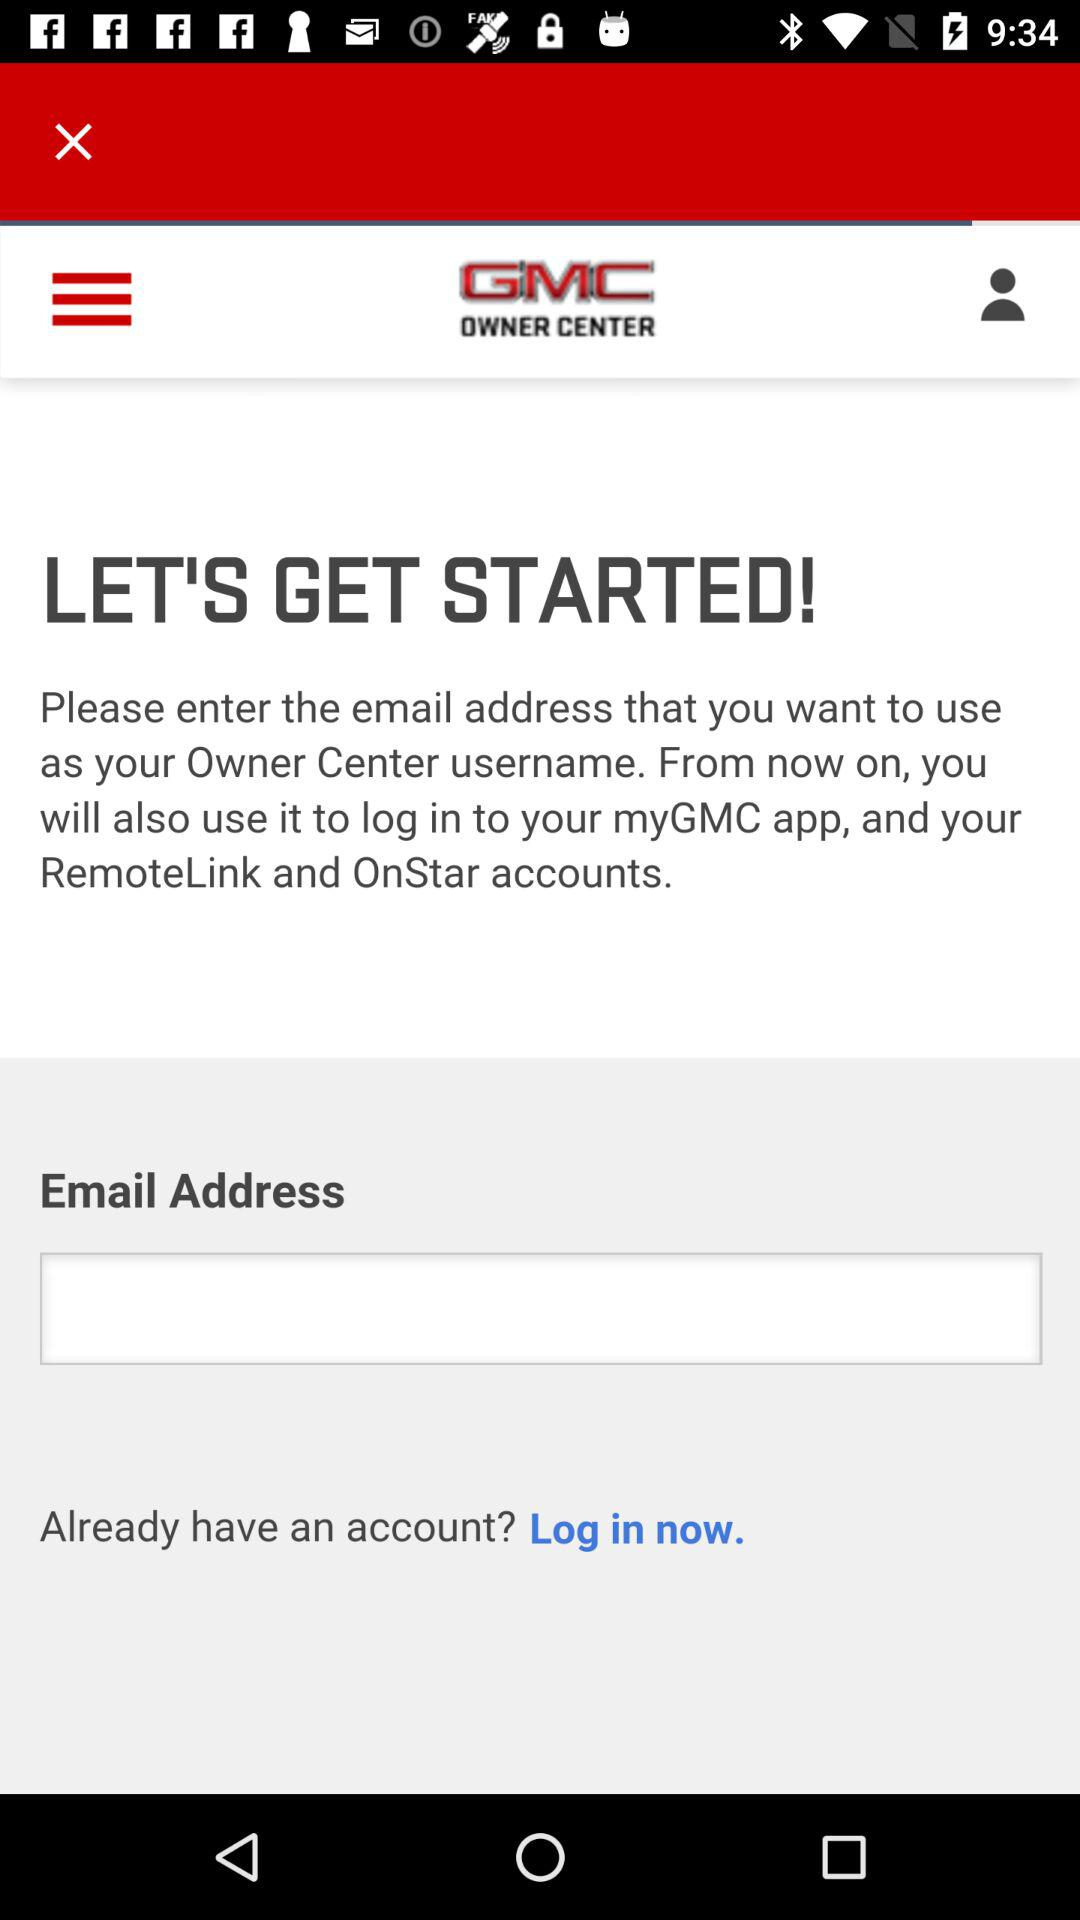What is the name of the application? The name of the application is "myGMC". 